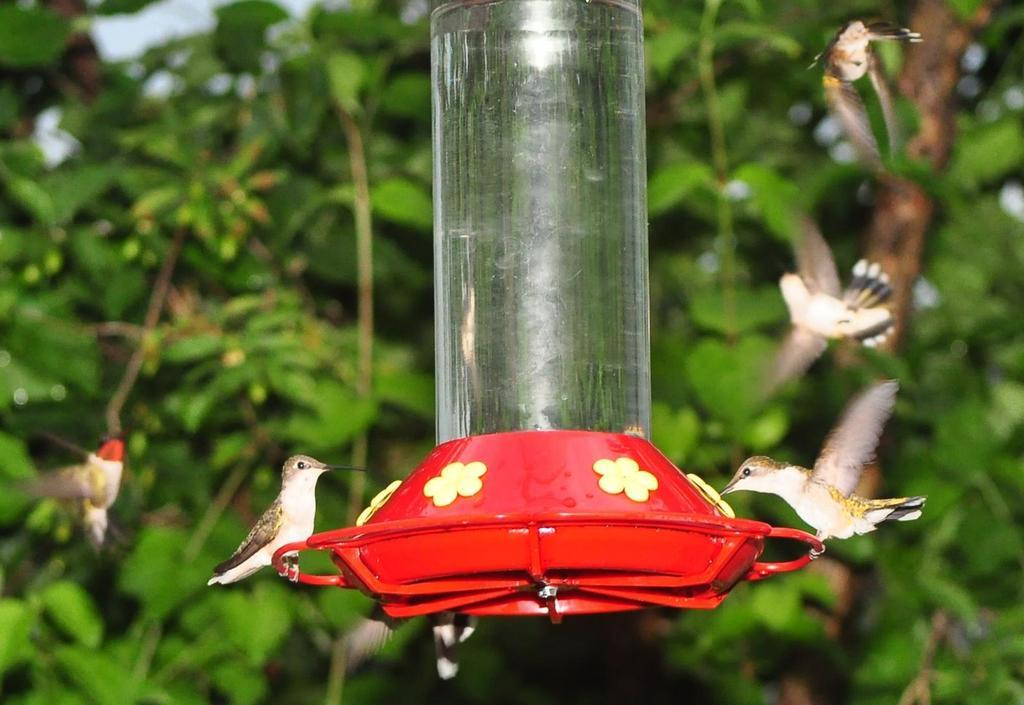What type of animals can be seen in the image? There are small birds in the image. What is the container in the image used for? The container in the image is used for water. What can be seen in the background of the image? Trees are present in the background of the image. What type of gun is being used by the birds in the image? There is no gun present in the image; it features small birds and a container with water. What type of tin can be seen in the image? There is no tin present in the image. 